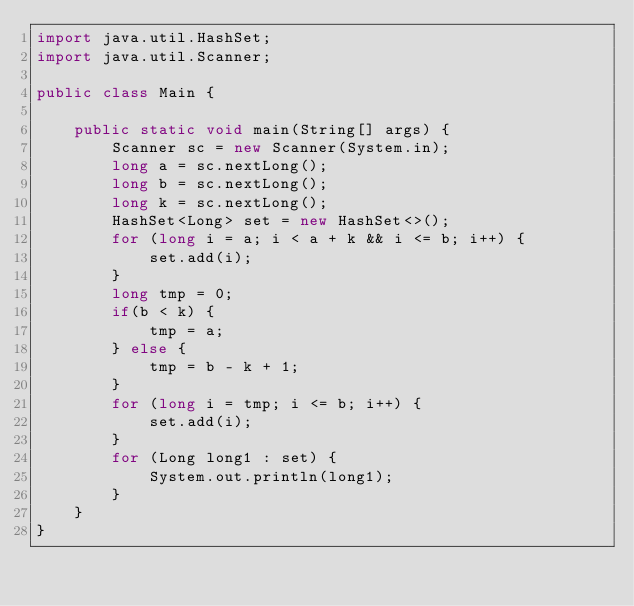Convert code to text. <code><loc_0><loc_0><loc_500><loc_500><_Java_>import java.util.HashSet;
import java.util.Scanner;

public class Main {

    public static void main(String[] args) {
        Scanner sc = new Scanner(System.in);
        long a = sc.nextLong();
        long b = sc.nextLong();
        long k = sc.nextLong();
        HashSet<Long> set = new HashSet<>();
        for (long i = a; i < a + k && i <= b; i++) {
            set.add(i);
        }
        long tmp = 0;
        if(b < k) {
            tmp = a;
        } else {
            tmp = b - k + 1;
        }
        for (long i = tmp; i <= b; i++) {
            set.add(i);
        }
        for (Long long1 : set) {
            System.out.println(long1);
        }
    }
}</code> 